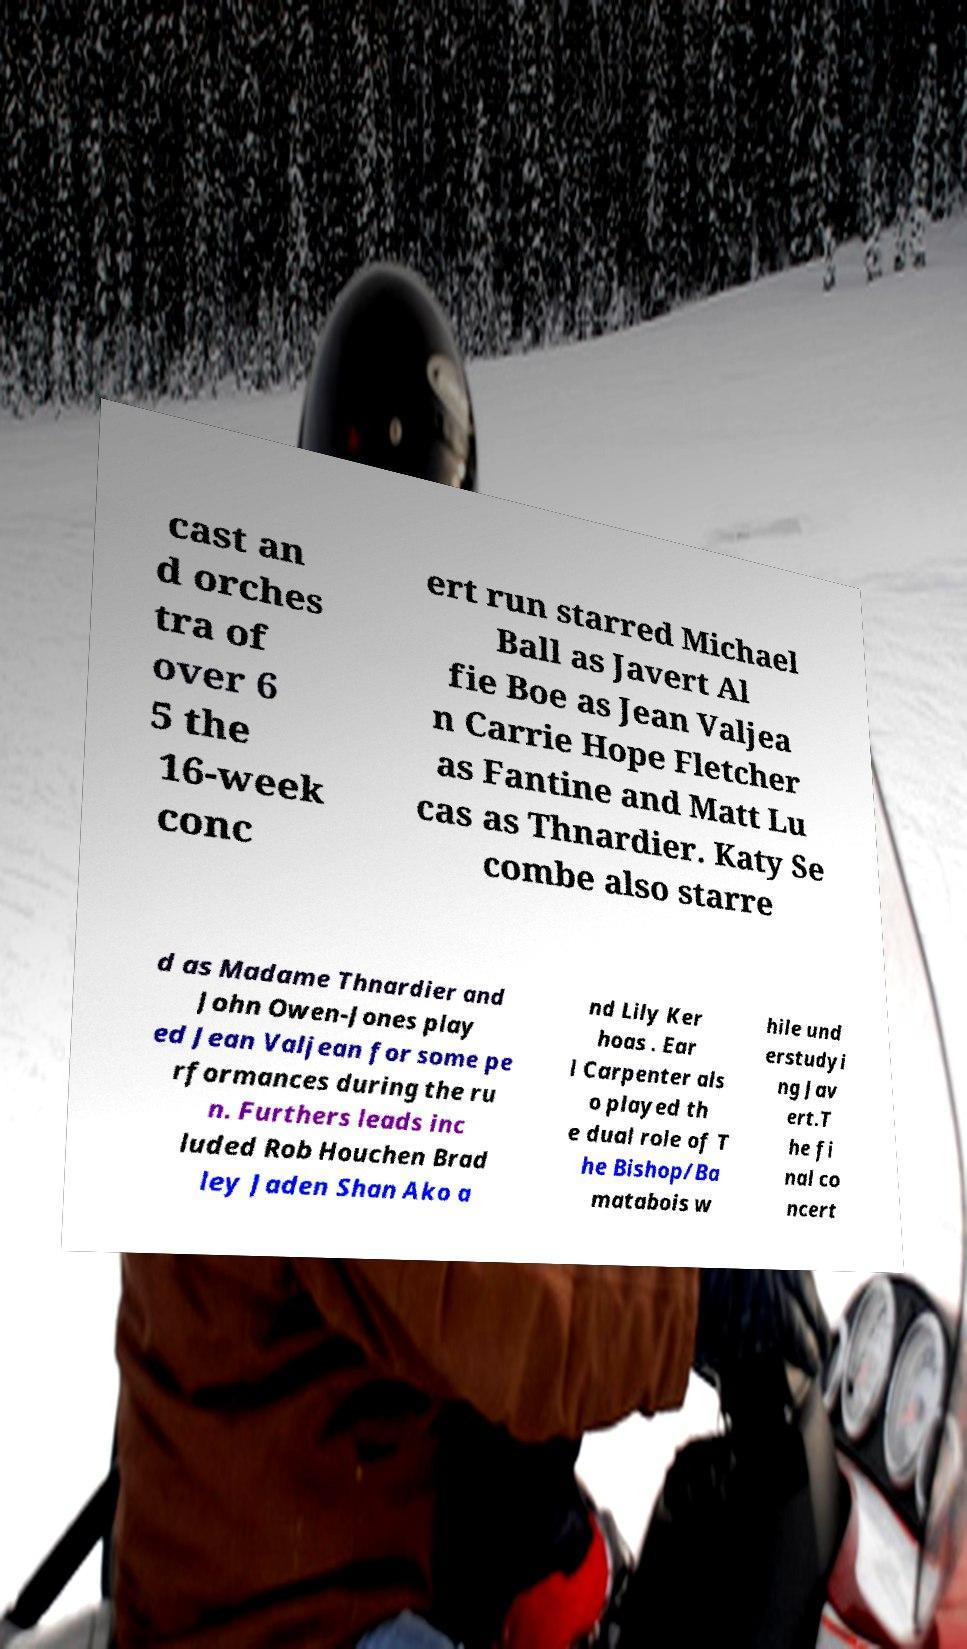I need the written content from this picture converted into text. Can you do that? cast an d orches tra of over 6 5 the 16-week conc ert run starred Michael Ball as Javert Al fie Boe as Jean Valjea n Carrie Hope Fletcher as Fantine and Matt Lu cas as Thnardier. Katy Se combe also starre d as Madame Thnardier and John Owen-Jones play ed Jean Valjean for some pe rformances during the ru n. Furthers leads inc luded Rob Houchen Brad ley Jaden Shan Ako a nd Lily Ker hoas . Ear l Carpenter als o played th e dual role of T he Bishop/Ba matabois w hile und erstudyi ng Jav ert.T he fi nal co ncert 